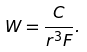<formula> <loc_0><loc_0><loc_500><loc_500>W = \frac { C } { r ^ { 3 } F } .</formula> 